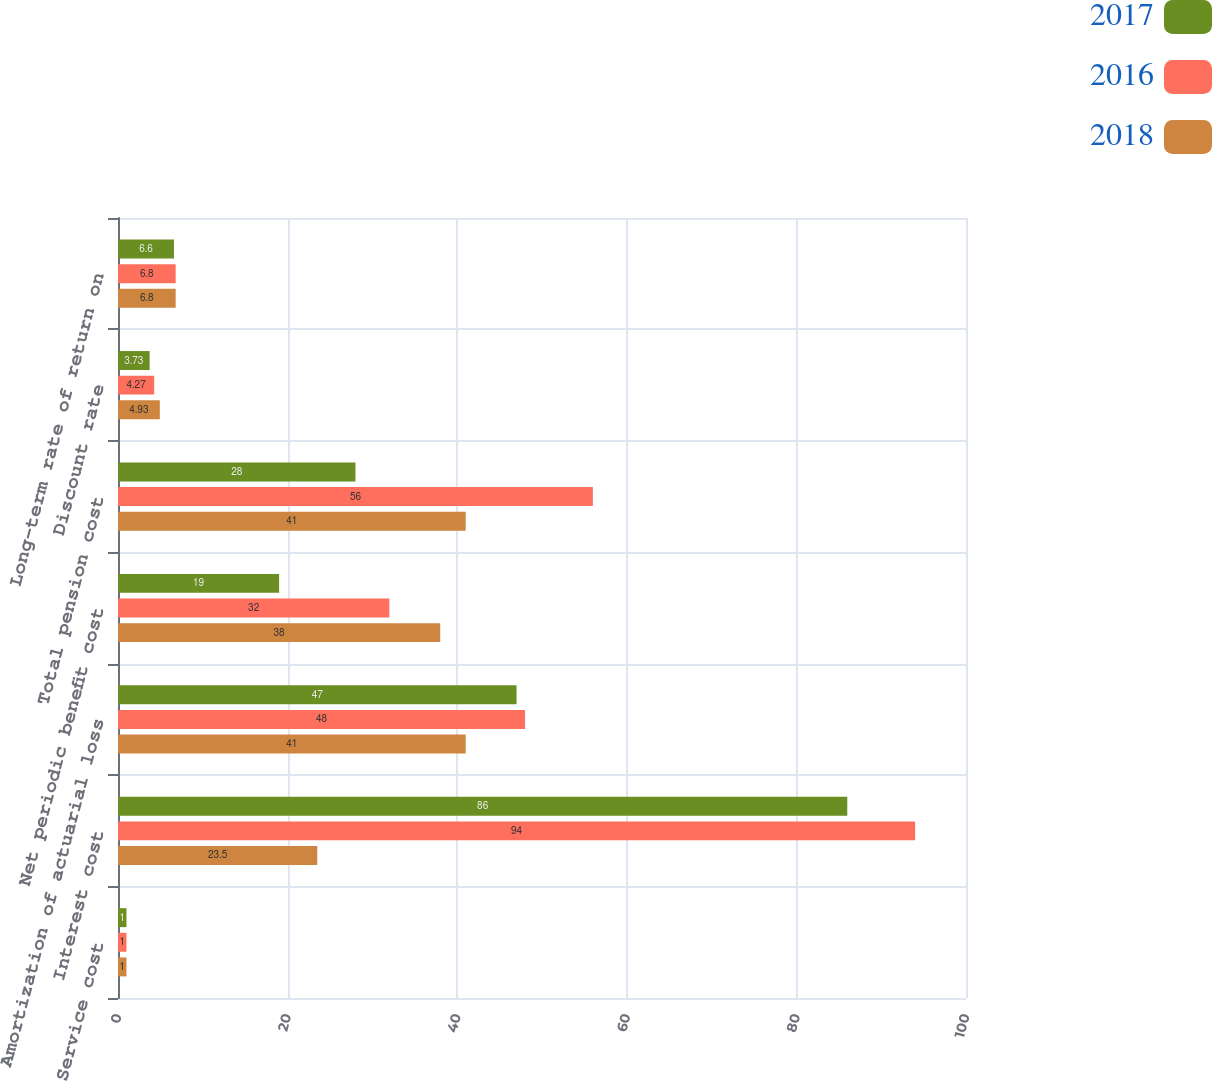<chart> <loc_0><loc_0><loc_500><loc_500><stacked_bar_chart><ecel><fcel>Service cost<fcel>Interest cost<fcel>Amortization of actuarial loss<fcel>Net periodic benefit cost<fcel>Total pension cost<fcel>Discount rate<fcel>Long-term rate of return on<nl><fcel>2017<fcel>1<fcel>86<fcel>47<fcel>19<fcel>28<fcel>3.73<fcel>6.6<nl><fcel>2016<fcel>1<fcel>94<fcel>48<fcel>32<fcel>56<fcel>4.27<fcel>6.8<nl><fcel>2018<fcel>1<fcel>23.5<fcel>41<fcel>38<fcel>41<fcel>4.93<fcel>6.8<nl></chart> 